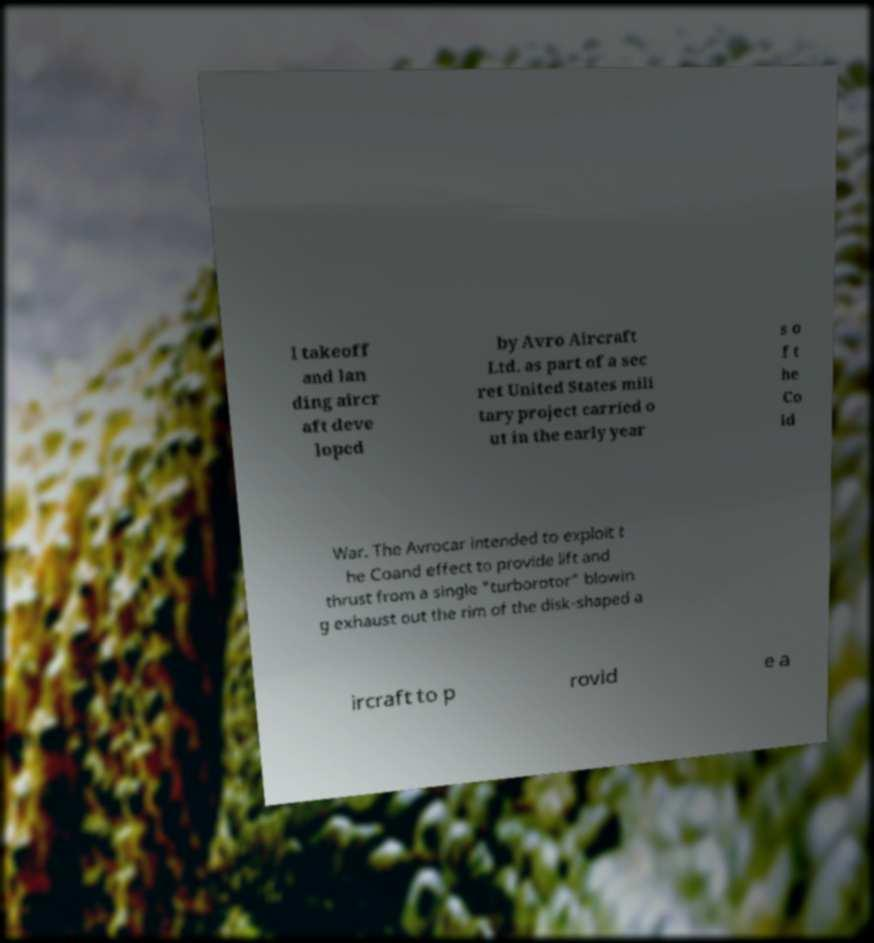Can you accurately transcribe the text from the provided image for me? l takeoff and lan ding aircr aft deve loped by Avro Aircraft Ltd. as part of a sec ret United States mili tary project carried o ut in the early year s o f t he Co ld War. The Avrocar intended to exploit t he Coand effect to provide lift and thrust from a single "turborotor" blowin g exhaust out the rim of the disk-shaped a ircraft to p rovid e a 